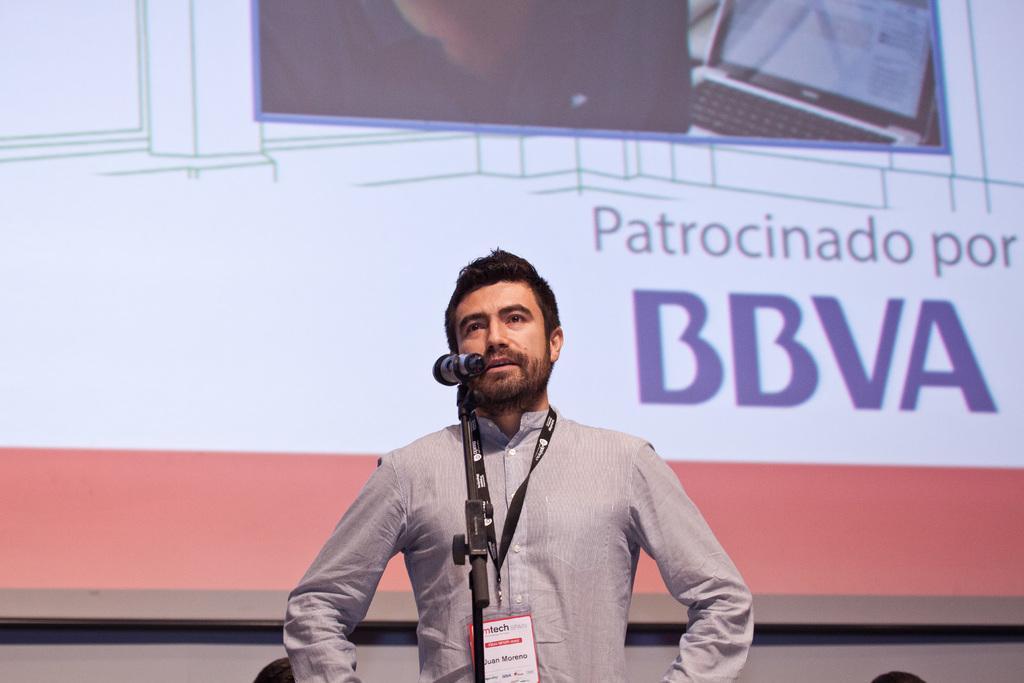Please provide a concise description of this image. In this image there is a mike, behind the mike there is a person standing, wearing shirt, and an id tag, in the background there is a screen on that screen there is some text and pictures. 